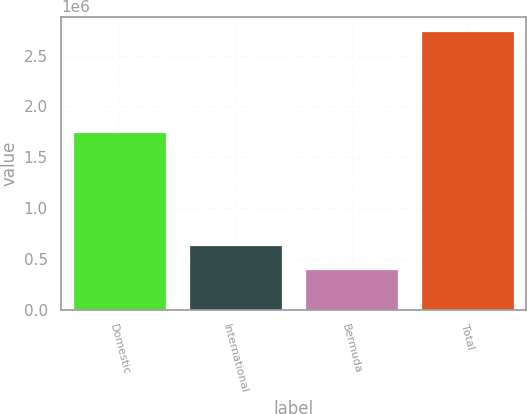Convert chart to OTSL. <chart><loc_0><loc_0><loc_500><loc_500><bar_chart><fcel>Domestic<fcel>International<fcel>Bermuda<fcel>Total<nl><fcel>1.75071e+06<fcel>641934<fcel>408230<fcel>2.74526e+06<nl></chart> 